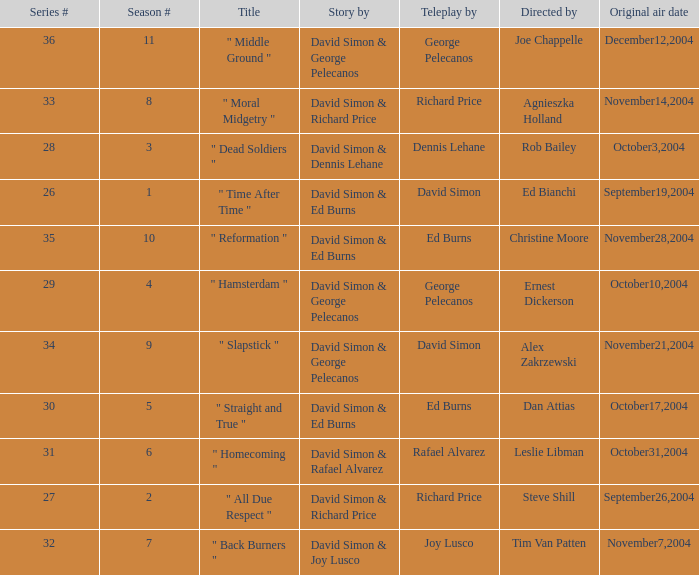What is the season # for a teleplay by Richard Price and the director is Steve Shill? 2.0. 